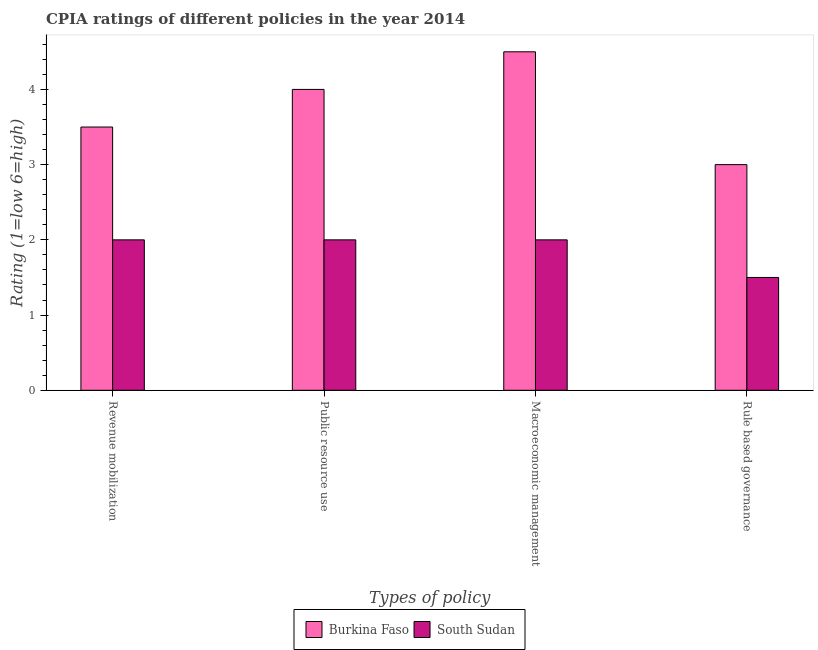How many groups of bars are there?
Provide a succinct answer. 4. Are the number of bars per tick equal to the number of legend labels?
Offer a terse response. Yes. How many bars are there on the 4th tick from the right?
Ensure brevity in your answer.  2. What is the label of the 4th group of bars from the left?
Your answer should be very brief. Rule based governance. What is the cpia rating of revenue mobilization in Burkina Faso?
Your answer should be compact. 3.5. Across all countries, what is the maximum cpia rating of macroeconomic management?
Keep it short and to the point. 4.5. Across all countries, what is the minimum cpia rating of macroeconomic management?
Keep it short and to the point. 2. In which country was the cpia rating of public resource use maximum?
Give a very brief answer. Burkina Faso. In which country was the cpia rating of macroeconomic management minimum?
Your answer should be compact. South Sudan. What is the total cpia rating of macroeconomic management in the graph?
Ensure brevity in your answer.  6.5. What is the difference between the cpia rating of revenue mobilization in Burkina Faso and the cpia rating of macroeconomic management in South Sudan?
Ensure brevity in your answer.  1.5. What is the ratio of the cpia rating of macroeconomic management in South Sudan to that in Burkina Faso?
Provide a succinct answer. 0.44. Is the cpia rating of revenue mobilization in Burkina Faso less than that in South Sudan?
Your response must be concise. No. What is the difference between the highest and the lowest cpia rating of revenue mobilization?
Provide a succinct answer. 1.5. In how many countries, is the cpia rating of revenue mobilization greater than the average cpia rating of revenue mobilization taken over all countries?
Ensure brevity in your answer.  1. Is the sum of the cpia rating of rule based governance in Burkina Faso and South Sudan greater than the maximum cpia rating of macroeconomic management across all countries?
Make the answer very short. No. Is it the case that in every country, the sum of the cpia rating of revenue mobilization and cpia rating of public resource use is greater than the sum of cpia rating of macroeconomic management and cpia rating of rule based governance?
Provide a succinct answer. No. What does the 2nd bar from the left in Public resource use represents?
Your response must be concise. South Sudan. What does the 2nd bar from the right in Public resource use represents?
Give a very brief answer. Burkina Faso. How many bars are there?
Keep it short and to the point. 8. How many countries are there in the graph?
Your answer should be compact. 2. What is the difference between two consecutive major ticks on the Y-axis?
Make the answer very short. 1. Does the graph contain grids?
Your answer should be compact. No. Where does the legend appear in the graph?
Give a very brief answer. Bottom center. How many legend labels are there?
Make the answer very short. 2. How are the legend labels stacked?
Offer a very short reply. Horizontal. What is the title of the graph?
Your response must be concise. CPIA ratings of different policies in the year 2014. What is the label or title of the X-axis?
Your response must be concise. Types of policy. What is the Rating (1=low 6=high) of Burkina Faso in Revenue mobilization?
Offer a very short reply. 3.5. What is the Rating (1=low 6=high) of South Sudan in Revenue mobilization?
Make the answer very short. 2. What is the Rating (1=low 6=high) in Burkina Faso in Public resource use?
Provide a short and direct response. 4. What is the Rating (1=low 6=high) of Burkina Faso in Macroeconomic management?
Provide a short and direct response. 4.5. Across all Types of policy, what is the maximum Rating (1=low 6=high) of South Sudan?
Ensure brevity in your answer.  2. Across all Types of policy, what is the minimum Rating (1=low 6=high) in Burkina Faso?
Ensure brevity in your answer.  3. What is the total Rating (1=low 6=high) of Burkina Faso in the graph?
Offer a very short reply. 15. What is the difference between the Rating (1=low 6=high) in South Sudan in Revenue mobilization and that in Public resource use?
Give a very brief answer. 0. What is the difference between the Rating (1=low 6=high) of Burkina Faso in Revenue mobilization and that in Rule based governance?
Offer a terse response. 0.5. What is the difference between the Rating (1=low 6=high) in South Sudan in Revenue mobilization and that in Rule based governance?
Your response must be concise. 0.5. What is the difference between the Rating (1=low 6=high) in Burkina Faso in Public resource use and that in Macroeconomic management?
Provide a succinct answer. -0.5. What is the difference between the Rating (1=low 6=high) in Burkina Faso in Public resource use and that in Rule based governance?
Keep it short and to the point. 1. What is the difference between the Rating (1=low 6=high) in Burkina Faso in Macroeconomic management and that in Rule based governance?
Provide a succinct answer. 1.5. What is the difference between the Rating (1=low 6=high) in South Sudan in Macroeconomic management and that in Rule based governance?
Offer a very short reply. 0.5. What is the difference between the Rating (1=low 6=high) in Burkina Faso in Revenue mobilization and the Rating (1=low 6=high) in South Sudan in Public resource use?
Give a very brief answer. 1.5. What is the difference between the Rating (1=low 6=high) of Burkina Faso in Revenue mobilization and the Rating (1=low 6=high) of South Sudan in Macroeconomic management?
Give a very brief answer. 1.5. What is the difference between the Rating (1=low 6=high) in Burkina Faso in Public resource use and the Rating (1=low 6=high) in South Sudan in Macroeconomic management?
Provide a short and direct response. 2. What is the difference between the Rating (1=low 6=high) in Burkina Faso in Public resource use and the Rating (1=low 6=high) in South Sudan in Rule based governance?
Your answer should be compact. 2.5. What is the average Rating (1=low 6=high) of Burkina Faso per Types of policy?
Offer a very short reply. 3.75. What is the average Rating (1=low 6=high) in South Sudan per Types of policy?
Your answer should be very brief. 1.88. What is the difference between the Rating (1=low 6=high) of Burkina Faso and Rating (1=low 6=high) of South Sudan in Macroeconomic management?
Provide a succinct answer. 2.5. What is the difference between the Rating (1=low 6=high) of Burkina Faso and Rating (1=low 6=high) of South Sudan in Rule based governance?
Provide a short and direct response. 1.5. What is the ratio of the Rating (1=low 6=high) of Burkina Faso in Revenue mobilization to that in Public resource use?
Offer a terse response. 0.88. What is the ratio of the Rating (1=low 6=high) in South Sudan in Revenue mobilization to that in Public resource use?
Your answer should be very brief. 1. What is the ratio of the Rating (1=low 6=high) of South Sudan in Revenue mobilization to that in Macroeconomic management?
Give a very brief answer. 1. What is the ratio of the Rating (1=low 6=high) of Burkina Faso in Public resource use to that in Macroeconomic management?
Offer a terse response. 0.89. What is the difference between the highest and the second highest Rating (1=low 6=high) of Burkina Faso?
Make the answer very short. 0.5. 